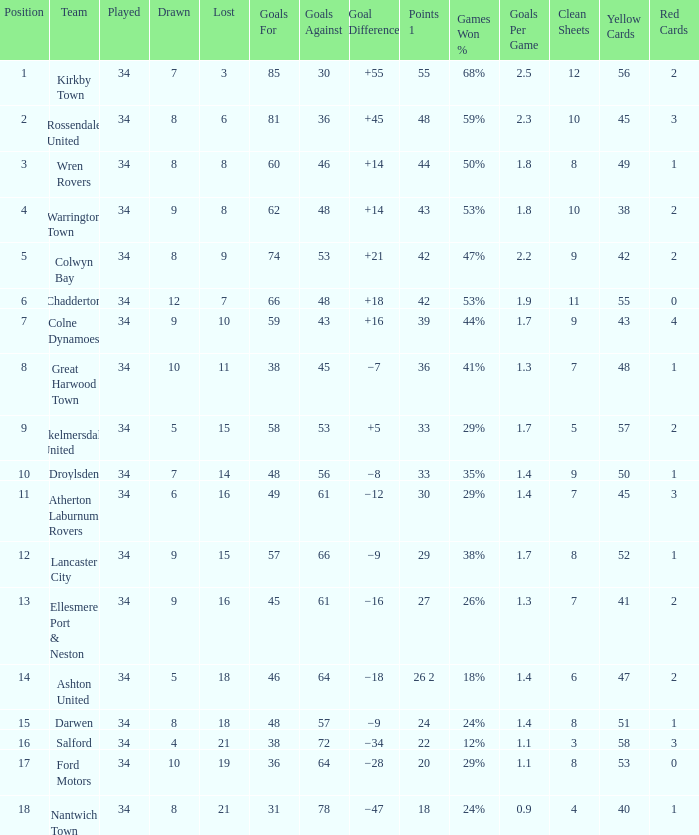What is the total number of goals for when the drawn is less than 7, less than 21 games have been lost, and there are 1 of 33 points? 1.0. 